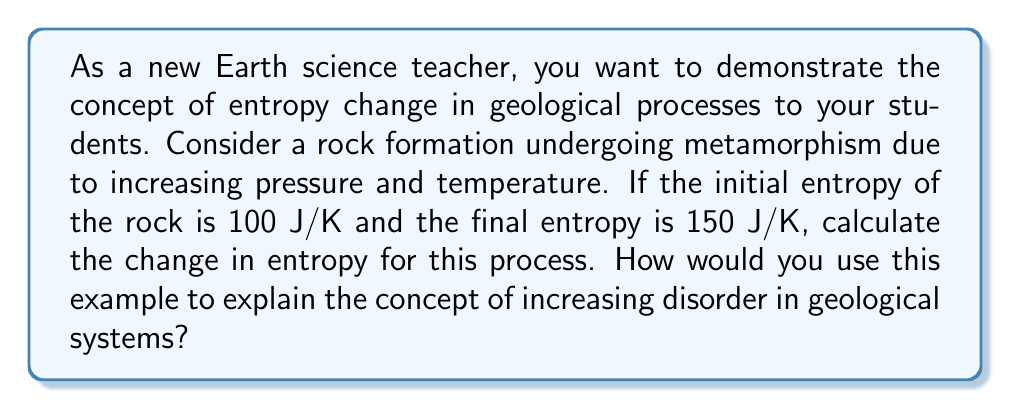Help me with this question. To calculate the change in entropy and explain the concept to students, follow these steps:

1. Identify the given information:
   - Initial entropy ($S_i$) = 100 J/K
   - Final entropy ($S_f$) = 150 J/K

2. Use the formula for change in entropy:
   $$\Delta S = S_f - S_i$$

3. Substitute the values:
   $$\Delta S = 150 \text{ J/K} - 100 \text{ J/K}$$

4. Calculate the result:
   $$\Delta S = 50 \text{ J/K}$$

5. Explain the concept of increasing disorder:
   - The positive change in entropy indicates an increase in disorder within the rock system.
   - During metamorphism, the rock's internal structure becomes more disordered due to increased temperature and pressure.
   - This disorder is reflected in changes such as recrystallization, formation of new minerals, and rearrangement of atoms.
   - The increase in entropy aligns with the Second Law of Thermodynamics, which states that the entropy of an isolated system always increases over time.

6. Relate to observable changes:
   - Students can visualize this increase in disorder by comparing the original rock's structure to the metamorphosed rock's appearance.
   - Examples include the formation of foliation in metamorphic rocks or the development of larger crystal sizes.

By using this calculation and explanation, students can better understand how entropy changes relate to real-world geological processes and the concept of increasing disorder in natural systems.
Answer: $\Delta S = 50 \text{ J/K}$ 